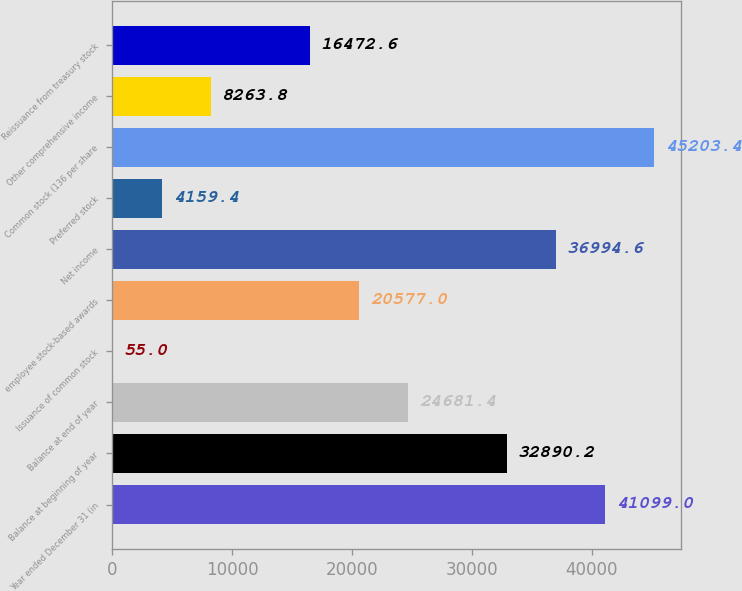Convert chart. <chart><loc_0><loc_0><loc_500><loc_500><bar_chart><fcel>Year ended December 31 (in<fcel>Balance at beginning of year<fcel>Balance at end of year<fcel>Issuance of common stock<fcel>employee stock-based awards<fcel>Net income<fcel>Preferred stock<fcel>Common stock (136 per share<fcel>Other comprehensive income<fcel>Reissuance from treasury stock<nl><fcel>41099<fcel>32890.2<fcel>24681.4<fcel>55<fcel>20577<fcel>36994.6<fcel>4159.4<fcel>45203.4<fcel>8263.8<fcel>16472.6<nl></chart> 